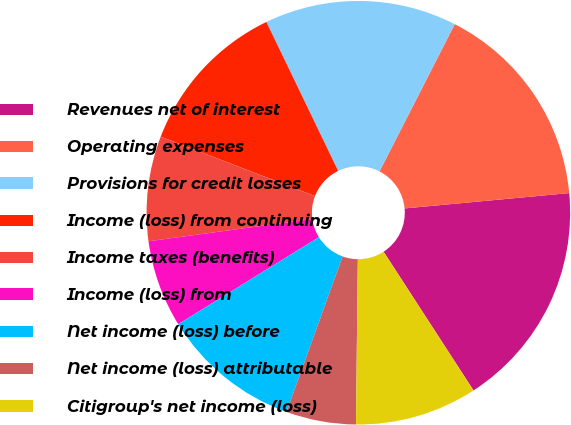<chart> <loc_0><loc_0><loc_500><loc_500><pie_chart><fcel>Revenues net of interest<fcel>Operating expenses<fcel>Provisions for credit losses<fcel>Income (loss) from continuing<fcel>Income taxes (benefits)<fcel>Income (loss) from<fcel>Net income (loss) before<fcel>Net income (loss) attributable<fcel>Citigroup's net income (loss)<nl><fcel>17.33%<fcel>16.0%<fcel>14.67%<fcel>12.0%<fcel>8.0%<fcel>6.67%<fcel>10.67%<fcel>5.33%<fcel>9.33%<nl></chart> 